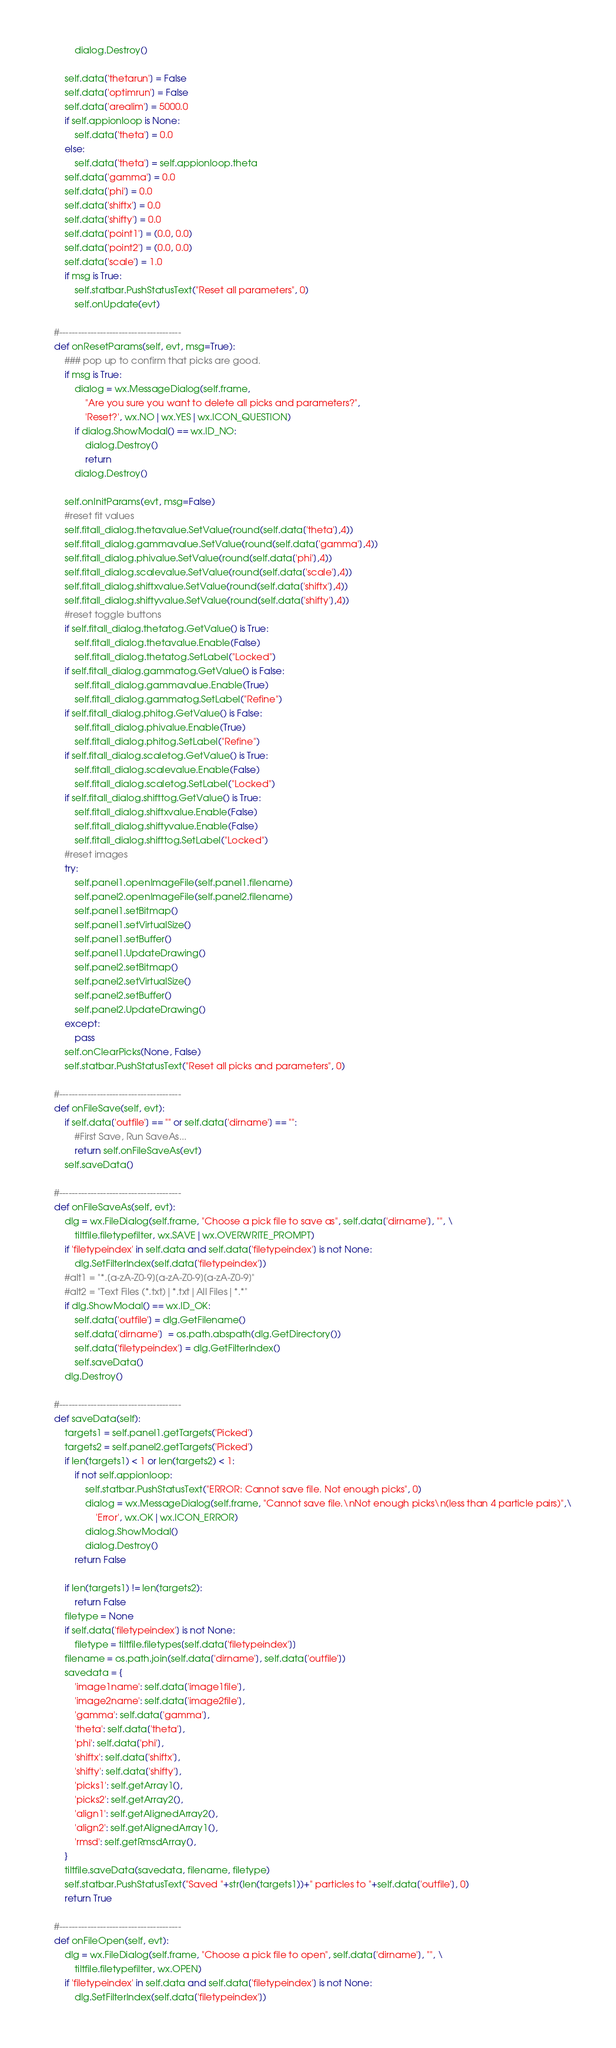<code> <loc_0><loc_0><loc_500><loc_500><_Python_>			dialog.Destroy()

		self.data['thetarun'] = False
		self.data['optimrun'] = False
		self.data['arealim'] = 5000.0
		if self.appionloop is None:
			self.data['theta'] = 0.0
		else:
			self.data['theta'] = self.appionloop.theta
		self.data['gamma'] = 0.0
		self.data['phi'] = 0.0
		self.data['shiftx'] = 0.0
		self.data['shifty'] = 0.0
		self.data['point1'] = (0.0, 0.0)
		self.data['point2'] = (0.0, 0.0)
		self.data['scale'] = 1.0
		if msg is True:
			self.statbar.PushStatusText("Reset all parameters", 0)
			self.onUpdate(evt)

	#---------------------------------------
	def onResetParams(self, evt, msg=True):
		### pop up to confirm that picks are good.
		if msg is True:
			dialog = wx.MessageDialog(self.frame,
				"Are you sure you want to delete all picks and parameters?", 
				'Reset?', wx.NO|wx.YES|wx.ICON_QUESTION)
			if dialog.ShowModal() == wx.ID_NO:
				dialog.Destroy()
				return
			dialog.Destroy()

		self.onInitParams(evt, msg=False)
		#reset fit values
		self.fitall_dialog.thetavalue.SetValue(round(self.data['theta'],4))
		self.fitall_dialog.gammavalue.SetValue(round(self.data['gamma'],4))
		self.fitall_dialog.phivalue.SetValue(round(self.data['phi'],4))
		self.fitall_dialog.scalevalue.SetValue(round(self.data['scale'],4))
		self.fitall_dialog.shiftxvalue.SetValue(round(self.data['shiftx'],4))
		self.fitall_dialog.shiftyvalue.SetValue(round(self.data['shifty'],4))
		#reset toggle buttons
		if self.fitall_dialog.thetatog.GetValue() is True:
			self.fitall_dialog.thetavalue.Enable(False)
			self.fitall_dialog.thetatog.SetLabel("Locked")
		if self.fitall_dialog.gammatog.GetValue() is False:
			self.fitall_dialog.gammavalue.Enable(True)
			self.fitall_dialog.gammatog.SetLabel("Refine")
		if self.fitall_dialog.phitog.GetValue() is False:
			self.fitall_dialog.phivalue.Enable(True)
			self.fitall_dialog.phitog.SetLabel("Refine")
		if self.fitall_dialog.scaletog.GetValue() is True:
			self.fitall_dialog.scalevalue.Enable(False)
			self.fitall_dialog.scaletog.SetLabel("Locked")
		if self.fitall_dialog.shifttog.GetValue() is True:
			self.fitall_dialog.shiftxvalue.Enable(False)
			self.fitall_dialog.shiftyvalue.Enable(False)
			self.fitall_dialog.shifttog.SetLabel("Locked")
		#reset images
		try:
			self.panel1.openImageFile(self.panel1.filename)
			self.panel2.openImageFile(self.panel2.filename)
			self.panel1.setBitmap()
			self.panel1.setVirtualSize()
			self.panel1.setBuffer()
			self.panel1.UpdateDrawing()
			self.panel2.setBitmap()
			self.panel2.setVirtualSize()
			self.panel2.setBuffer()
			self.panel2.UpdateDrawing()
		except:
			pass
		self.onClearPicks(None, False)
		self.statbar.PushStatusText("Reset all picks and parameters", 0)

	#---------------------------------------
	def onFileSave(self, evt):
		if self.data['outfile'] == "" or self.data['dirname'] == "":
			#First Save, Run SaveAs...
			return self.onFileSaveAs(evt)
		self.saveData()

	#---------------------------------------
	def onFileSaveAs(self, evt):
		dlg = wx.FileDialog(self.frame, "Choose a pick file to save as", self.data['dirname'], "", \
			tiltfile.filetypefilter, wx.SAVE|wx.OVERWRITE_PROMPT)
		if 'filetypeindex' in self.data and self.data['filetypeindex'] is not None:
			dlg.SetFilterIndex(self.data['filetypeindex'])
		#alt1 = "*.[a-zA-Z0-9][a-zA-Z0-9][a-zA-Z0-9]"
		#alt2 = "Text Files (*.txt)|*.txt|All Files|*.*"
		if dlg.ShowModal() == wx.ID_OK:
			self.data['outfile'] = dlg.GetFilename()
			self.data['dirname']  = os.path.abspath(dlg.GetDirectory())
			self.data['filetypeindex'] = dlg.GetFilterIndex()
			self.saveData()
		dlg.Destroy()

	#---------------------------------------
	def saveData(self):
		targets1 = self.panel1.getTargets('Picked')
		targets2 = self.panel2.getTargets('Picked')
		if len(targets1) < 1 or len(targets2) < 1:
			if not self.appionloop:
				self.statbar.PushStatusText("ERROR: Cannot save file. Not enough picks", 0)
				dialog = wx.MessageDialog(self.frame, "Cannot save file.\nNot enough picks\n(less than 4 particle pairs)",\
					'Error', wx.OK|wx.ICON_ERROR)
				dialog.ShowModal()
				dialog.Destroy()
			return False

		if len(targets1) != len(targets2):
			return False
		filetype = None
		if self.data['filetypeindex'] is not None:
			filetype = tiltfile.filetypes[self.data['filetypeindex']]
		filename = os.path.join(self.data['dirname'], self.data['outfile'])
		savedata = {
			'image1name': self.data['image1file'],
			'image2name': self.data['image2file'],
			'gamma': self.data['gamma'],
			'theta': self.data['theta'],
			'phi': self.data['phi'],
			'shiftx': self.data['shiftx'],
			'shifty': self.data['shifty'],
			'picks1': self.getArray1(),
			'picks2': self.getArray2(),
			'align1': self.getAlignedArray2(),
			'align2': self.getAlignedArray1(),
			'rmsd': self.getRmsdArray(),
		}
		tiltfile.saveData(savedata, filename, filetype)
		self.statbar.PushStatusText("Saved "+str(len(targets1))+" particles to "+self.data['outfile'], 0)
		return True

	#---------------------------------------
	def onFileOpen(self, evt):
		dlg = wx.FileDialog(self.frame, "Choose a pick file to open", self.data['dirname'], "", \
			tiltfile.filetypefilter, wx.OPEN)
		if 'filetypeindex' in self.data and self.data['filetypeindex'] is not None:
			dlg.SetFilterIndex(self.data['filetypeindex'])</code> 